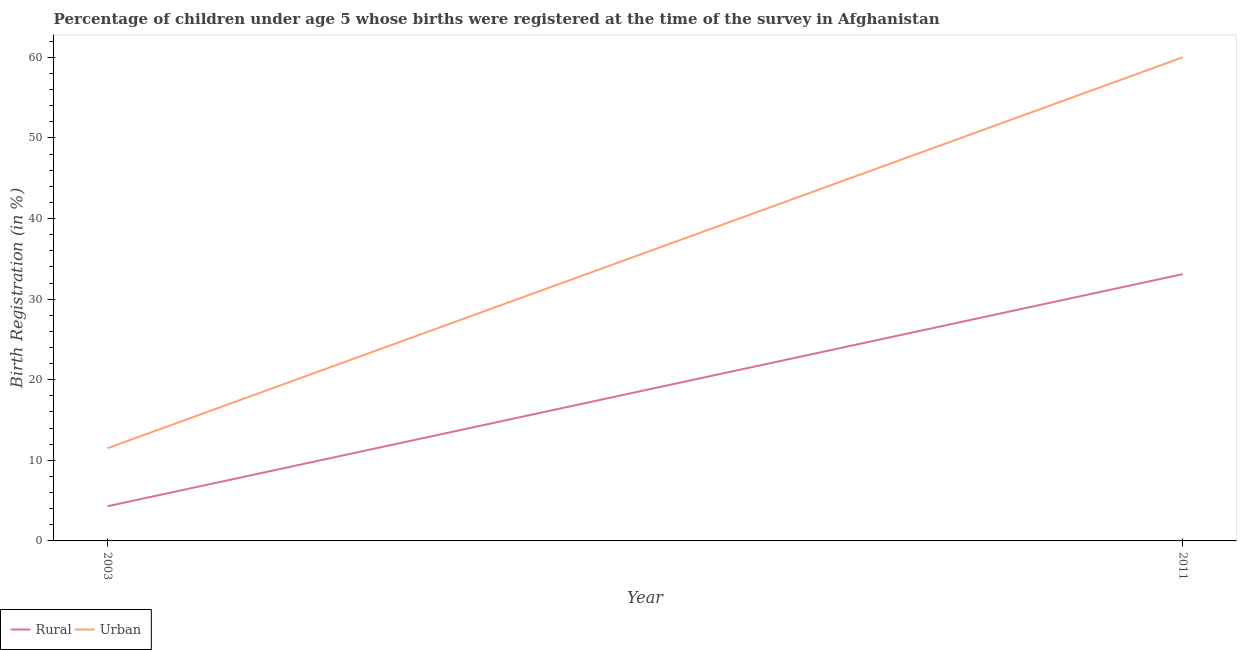Does the line corresponding to rural birth registration intersect with the line corresponding to urban birth registration?
Your answer should be very brief. No. Is the number of lines equal to the number of legend labels?
Keep it short and to the point. Yes. What is the urban birth registration in 2011?
Provide a short and direct response. 60. Across all years, what is the maximum rural birth registration?
Offer a very short reply. 33.1. What is the total urban birth registration in the graph?
Make the answer very short. 71.5. What is the difference between the urban birth registration in 2003 and that in 2011?
Keep it short and to the point. -48.5. What is the difference between the urban birth registration in 2003 and the rural birth registration in 2011?
Your response must be concise. -21.6. What is the average urban birth registration per year?
Your answer should be very brief. 35.75. In the year 2003, what is the difference between the urban birth registration and rural birth registration?
Offer a terse response. 7.2. What is the ratio of the urban birth registration in 2003 to that in 2011?
Provide a short and direct response. 0.19. Is the urban birth registration in 2003 less than that in 2011?
Offer a terse response. Yes. In how many years, is the rural birth registration greater than the average rural birth registration taken over all years?
Provide a succinct answer. 1. Does the urban birth registration monotonically increase over the years?
Give a very brief answer. Yes. How many years are there in the graph?
Provide a short and direct response. 2. What is the difference between two consecutive major ticks on the Y-axis?
Give a very brief answer. 10. Are the values on the major ticks of Y-axis written in scientific E-notation?
Your answer should be compact. No. Does the graph contain grids?
Your answer should be very brief. No. What is the title of the graph?
Provide a short and direct response. Percentage of children under age 5 whose births were registered at the time of the survey in Afghanistan. What is the label or title of the X-axis?
Provide a short and direct response. Year. What is the label or title of the Y-axis?
Provide a short and direct response. Birth Registration (in %). What is the Birth Registration (in %) of Urban in 2003?
Keep it short and to the point. 11.5. What is the Birth Registration (in %) of Rural in 2011?
Ensure brevity in your answer.  33.1. Across all years, what is the maximum Birth Registration (in %) in Rural?
Provide a succinct answer. 33.1. Across all years, what is the maximum Birth Registration (in %) in Urban?
Ensure brevity in your answer.  60. Across all years, what is the minimum Birth Registration (in %) in Rural?
Give a very brief answer. 4.3. Across all years, what is the minimum Birth Registration (in %) in Urban?
Provide a succinct answer. 11.5. What is the total Birth Registration (in %) in Rural in the graph?
Ensure brevity in your answer.  37.4. What is the total Birth Registration (in %) in Urban in the graph?
Provide a short and direct response. 71.5. What is the difference between the Birth Registration (in %) of Rural in 2003 and that in 2011?
Ensure brevity in your answer.  -28.8. What is the difference between the Birth Registration (in %) in Urban in 2003 and that in 2011?
Offer a terse response. -48.5. What is the difference between the Birth Registration (in %) in Rural in 2003 and the Birth Registration (in %) in Urban in 2011?
Offer a terse response. -55.7. What is the average Birth Registration (in %) of Rural per year?
Keep it short and to the point. 18.7. What is the average Birth Registration (in %) in Urban per year?
Your answer should be very brief. 35.75. In the year 2003, what is the difference between the Birth Registration (in %) in Rural and Birth Registration (in %) in Urban?
Your response must be concise. -7.2. In the year 2011, what is the difference between the Birth Registration (in %) of Rural and Birth Registration (in %) of Urban?
Your answer should be compact. -26.9. What is the ratio of the Birth Registration (in %) in Rural in 2003 to that in 2011?
Make the answer very short. 0.13. What is the ratio of the Birth Registration (in %) in Urban in 2003 to that in 2011?
Offer a terse response. 0.19. What is the difference between the highest and the second highest Birth Registration (in %) in Rural?
Give a very brief answer. 28.8. What is the difference between the highest and the second highest Birth Registration (in %) of Urban?
Ensure brevity in your answer.  48.5. What is the difference between the highest and the lowest Birth Registration (in %) of Rural?
Provide a succinct answer. 28.8. What is the difference between the highest and the lowest Birth Registration (in %) in Urban?
Your answer should be very brief. 48.5. 